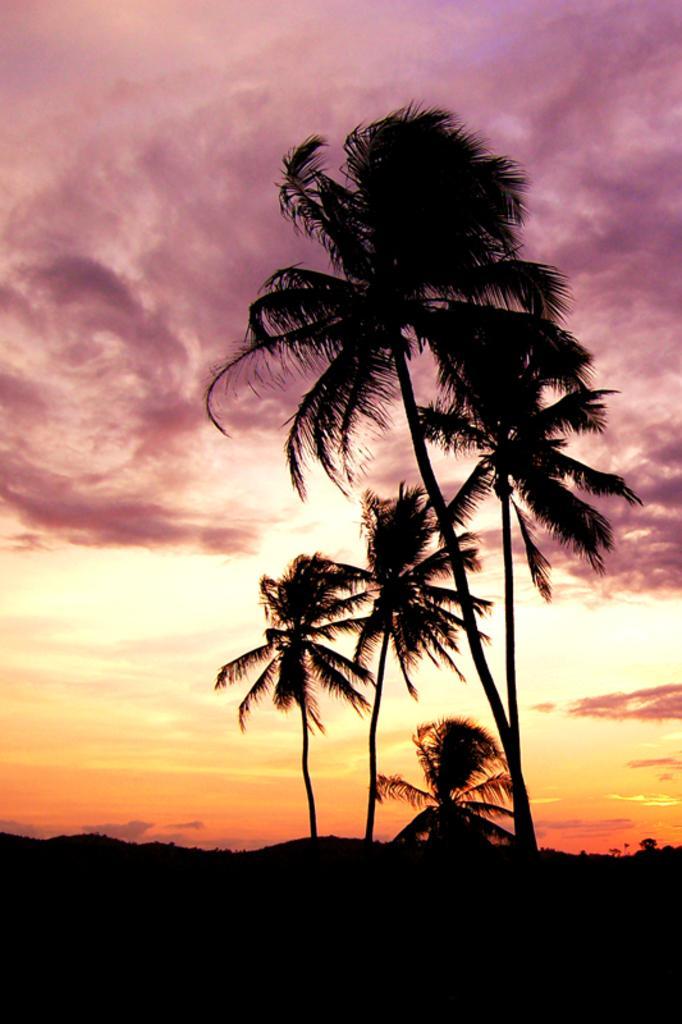Describe this image in one or two sentences. In this image we can see trees. In the background there is sky with clouds. And the image is dark. 